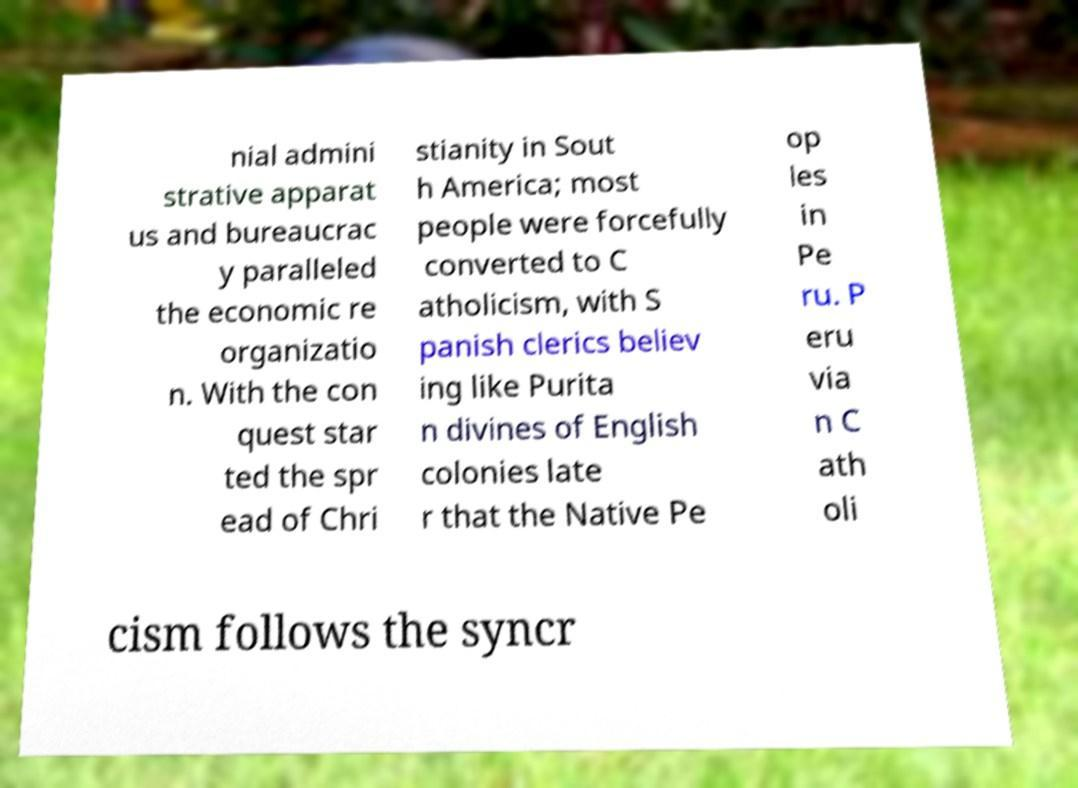Could you assist in decoding the text presented in this image and type it out clearly? nial admini strative apparat us and bureaucrac y paralleled the economic re organizatio n. With the con quest star ted the spr ead of Chri stianity in Sout h America; most people were forcefully converted to C atholicism, with S panish clerics believ ing like Purita n divines of English colonies late r that the Native Pe op les in Pe ru. P eru via n C ath oli cism follows the syncr 